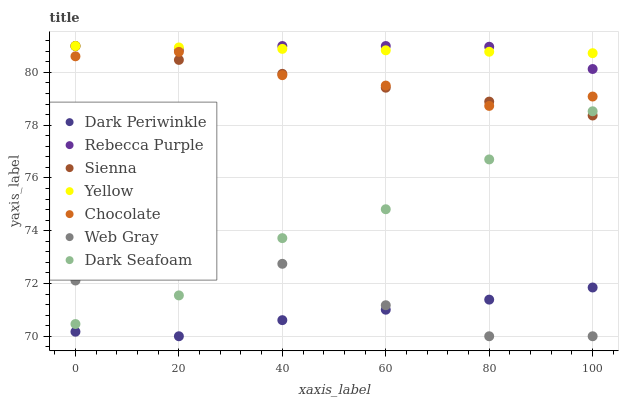Does Dark Periwinkle have the minimum area under the curve?
Answer yes or no. Yes. Does Rebecca Purple have the maximum area under the curve?
Answer yes or no. Yes. Does Yellow have the minimum area under the curve?
Answer yes or no. No. Does Yellow have the maximum area under the curve?
Answer yes or no. No. Is Sienna the smoothest?
Answer yes or no. Yes. Is Web Gray the roughest?
Answer yes or no. Yes. Is Yellow the smoothest?
Answer yes or no. No. Is Yellow the roughest?
Answer yes or no. No. Does Web Gray have the lowest value?
Answer yes or no. Yes. Does Chocolate have the lowest value?
Answer yes or no. No. Does Rebecca Purple have the highest value?
Answer yes or no. Yes. Does Chocolate have the highest value?
Answer yes or no. No. Is Chocolate less than Yellow?
Answer yes or no. Yes. Is Rebecca Purple greater than Dark Periwinkle?
Answer yes or no. Yes. Does Sienna intersect Yellow?
Answer yes or no. Yes. Is Sienna less than Yellow?
Answer yes or no. No. Is Sienna greater than Yellow?
Answer yes or no. No. Does Chocolate intersect Yellow?
Answer yes or no. No. 